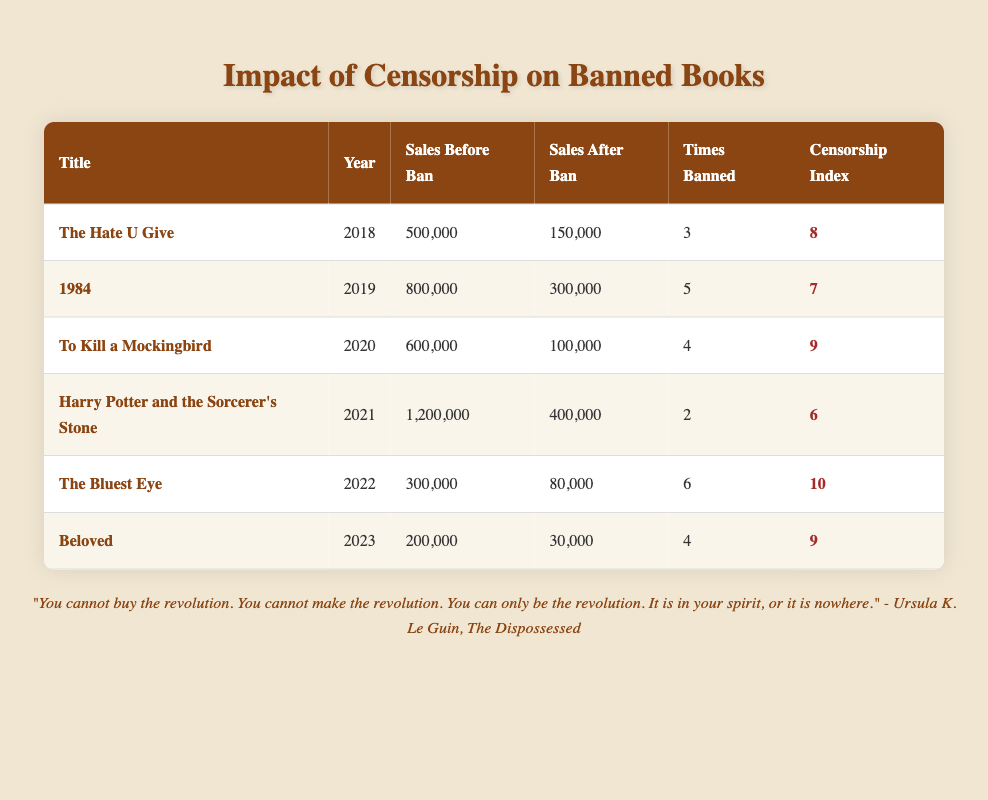What is the title of the book that had the highest sales before its ban? According to the table, "Harry Potter and the Sorcerer's Stone" had the highest sales before its ban, with 1,200,000 units sold.
Answer: Harry Potter and the Sorcerer's Stone Which book experienced the largest drop in sales after being banned? To find the drop in sales, we can subtract the sales after the ban from the sales before the ban for each book. "The Hate U Give" had a drop from 500,000 to 150,000, which is a drop of 350,000. "1984" had a drop of 500,000 units, "To Kill a Mockingbird" 500,000, "Harry Potter and the Sorcerer's Stone" 800,000, "The Bluest Eye" 220,000, and "Beloved" 170,000. The largest drop is 800,000 for "Harry Potter and the Sorcerer's Stone."
Answer: Harry Potter and the Sorcerer's Stone What is the average censorship index for all banned books in this table? The censorship indices are 8, 7, 9, 6, 10, and 9. Adding them up gives 49. There are 6 books, so the average is 49 divided by 6, which is approximately 8.17.
Answer: 8.17 How many times was "The Bluest Eye" banned? The table shows that "The Bluest Eye" was banned 6 times.
Answer: 6 Is it true that "1984" had higher sales after its ban compared to "Beloved"? To answer this, we compare the sales after the ban for both books. "1984" had sales of 300,000 after the ban, while "Beloved" had only 30,000. Since 300,000 is greater than 30,000, the statement is true.
Answer: Yes Which book was banned the most number of times and what was its censorship index? The book that was banned the most times is "The Bluest Eye," which was banned 6 times. Its censorship index is 10.
Answer: The Bluest Eye, 10 What is the total sales before ban for all books listed? To find total sales before the ban, we sum the sales: 500,000 + 800,000 + 600,000 + 1,200,000 + 300,000 + 200,000. The total is 2,600,000.
Answer: 2,600,000 Is the censorship index for "The Hate U Give" less than that for "Harry Potter and the Sorcerer's Stone"? Checking the censorship indices, "The Hate U Give" has an index of 8 and "Harry Potter and the Sorcerer's Stone" has an index of 6. Since 8 is not less than 6, the statement is false.
Answer: No 